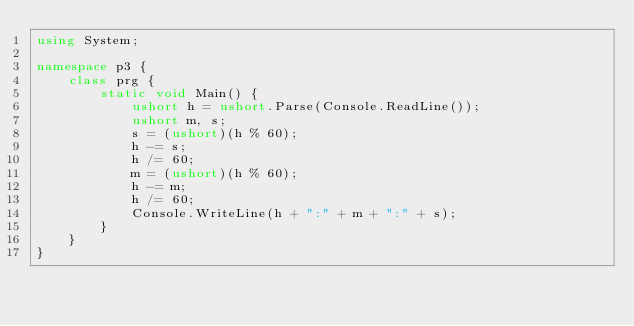<code> <loc_0><loc_0><loc_500><loc_500><_C#_>using System;

namespace p3 {
	class prg {
		static void Main() {
			ushort h = ushort.Parse(Console.ReadLine());
			ushort m, s;
			s = (ushort)(h % 60);
			h -= s;
			h /= 60;
			m = (ushort)(h % 60);
			h -= m;
			h /= 60;
			Console.WriteLine(h + ":" + m + ":" + s);
		}
	}
}</code> 